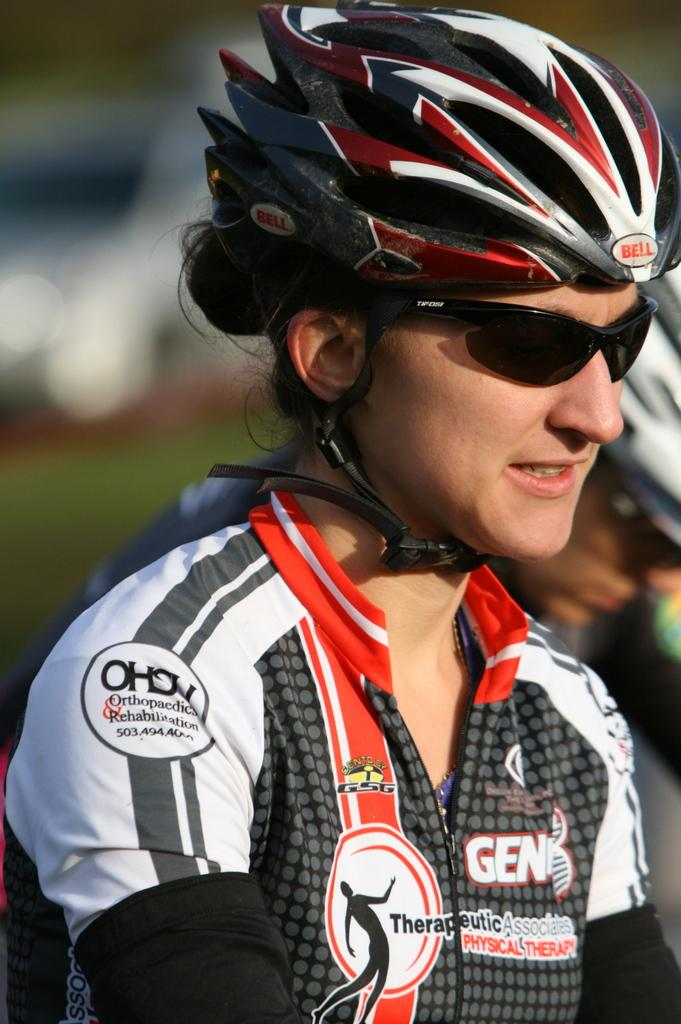What is the main subject in the foreground of the image? There is a person in the foreground of the image. What can be observed about the person in the foreground? The person in the foreground is wearing spectacles and a helmet. Can you describe the person in the background of the image? There is another person in the background of the image, and they are also wearing a helmet. How is the background of the image depicted? The background is blurred. What type of salt is being used by the person in the image? There is no salt present in the image, and therefore no such activity can be observed. What is the person in the image working on? The image does not provide information about what the person might be working on. 